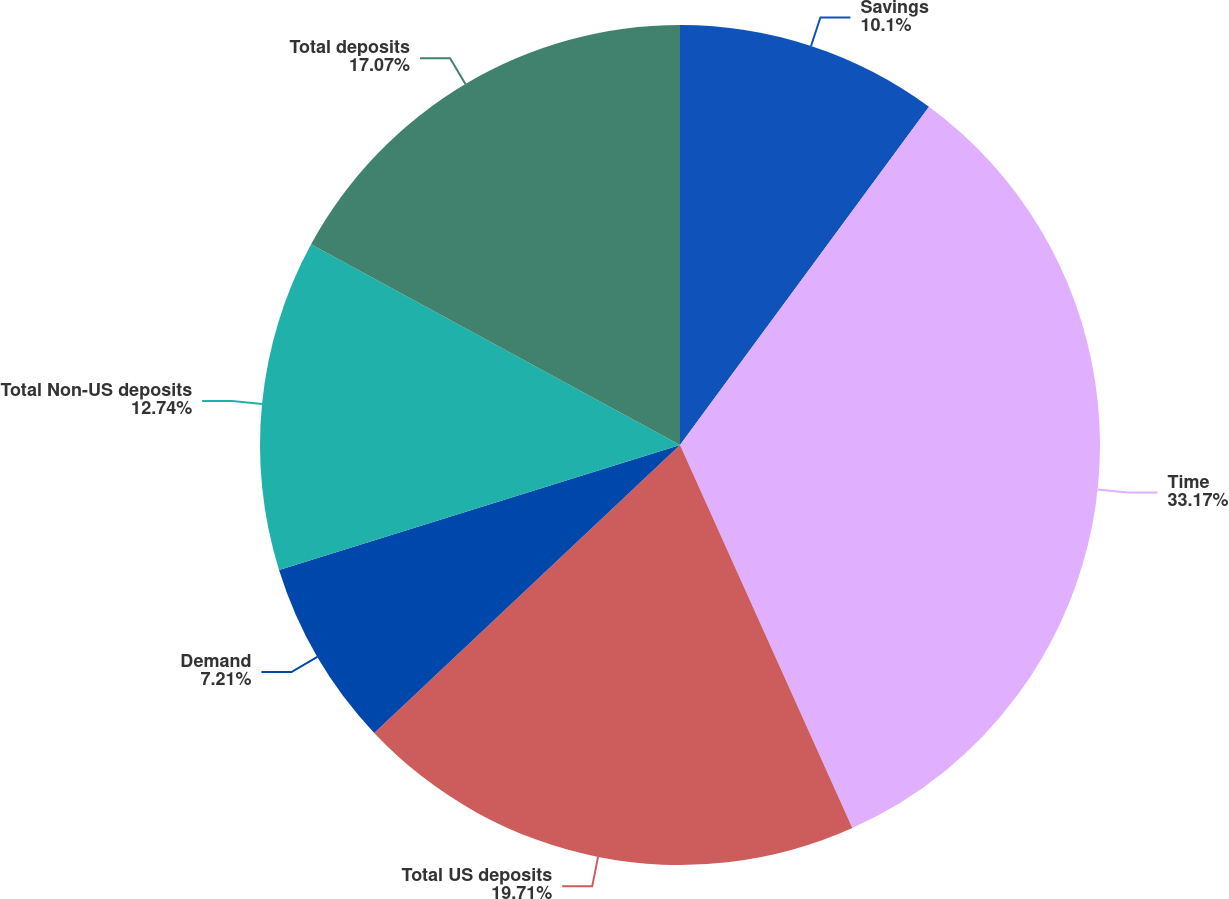<chart> <loc_0><loc_0><loc_500><loc_500><pie_chart><fcel>Savings<fcel>Time<fcel>Total US deposits<fcel>Demand<fcel>Total Non-US deposits<fcel>Total deposits<nl><fcel>10.1%<fcel>33.17%<fcel>19.71%<fcel>7.21%<fcel>12.74%<fcel>17.07%<nl></chart> 